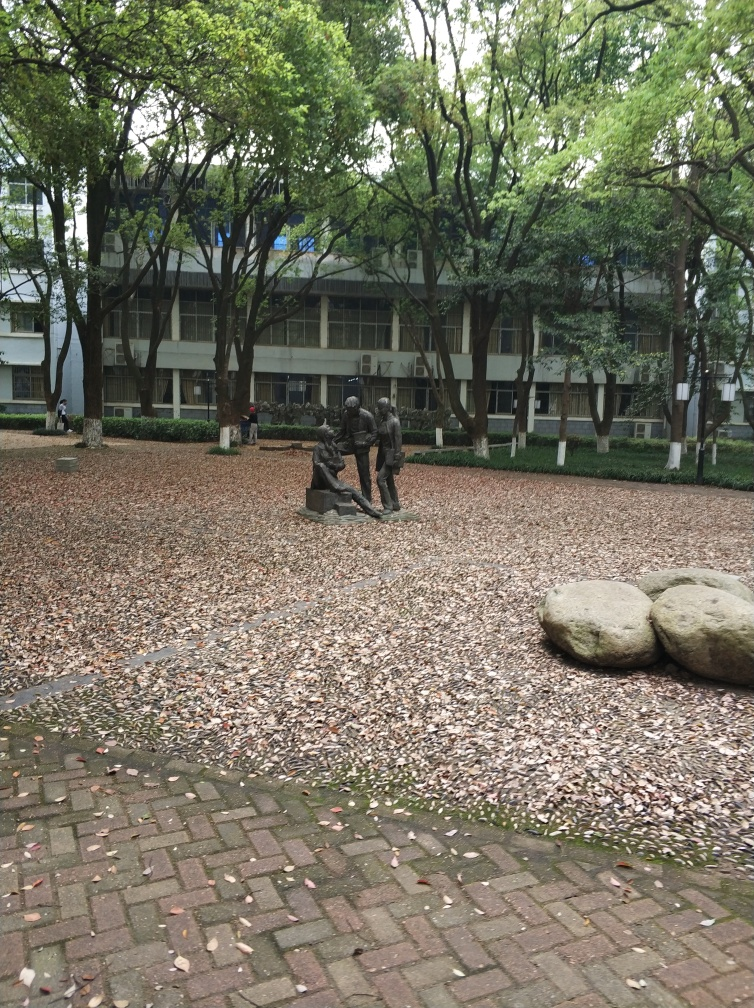What's the architectural style of the building in the background? The visible architecture of the building suggests a modern or contemporary style, characterized by its functional form, large glass surfaces, and minimal decorative elements. It likely dates back to the mid-to-late 20th century, as indicated by its geometric simplicity and use of materials common in that era. Are there any other interesting details in the image? In addition to the primary elements mentioned, you may notice subtle details like the different shades of leaves that speak to the diversity of tree species present. The pavement combines patterned brickwork with occasional large stones, enhancing the textural interplay. The sparse presence of people in the background provides a sense of scale and spatial awareness. Each component plays a role in framing this calm and cohesive environment. 